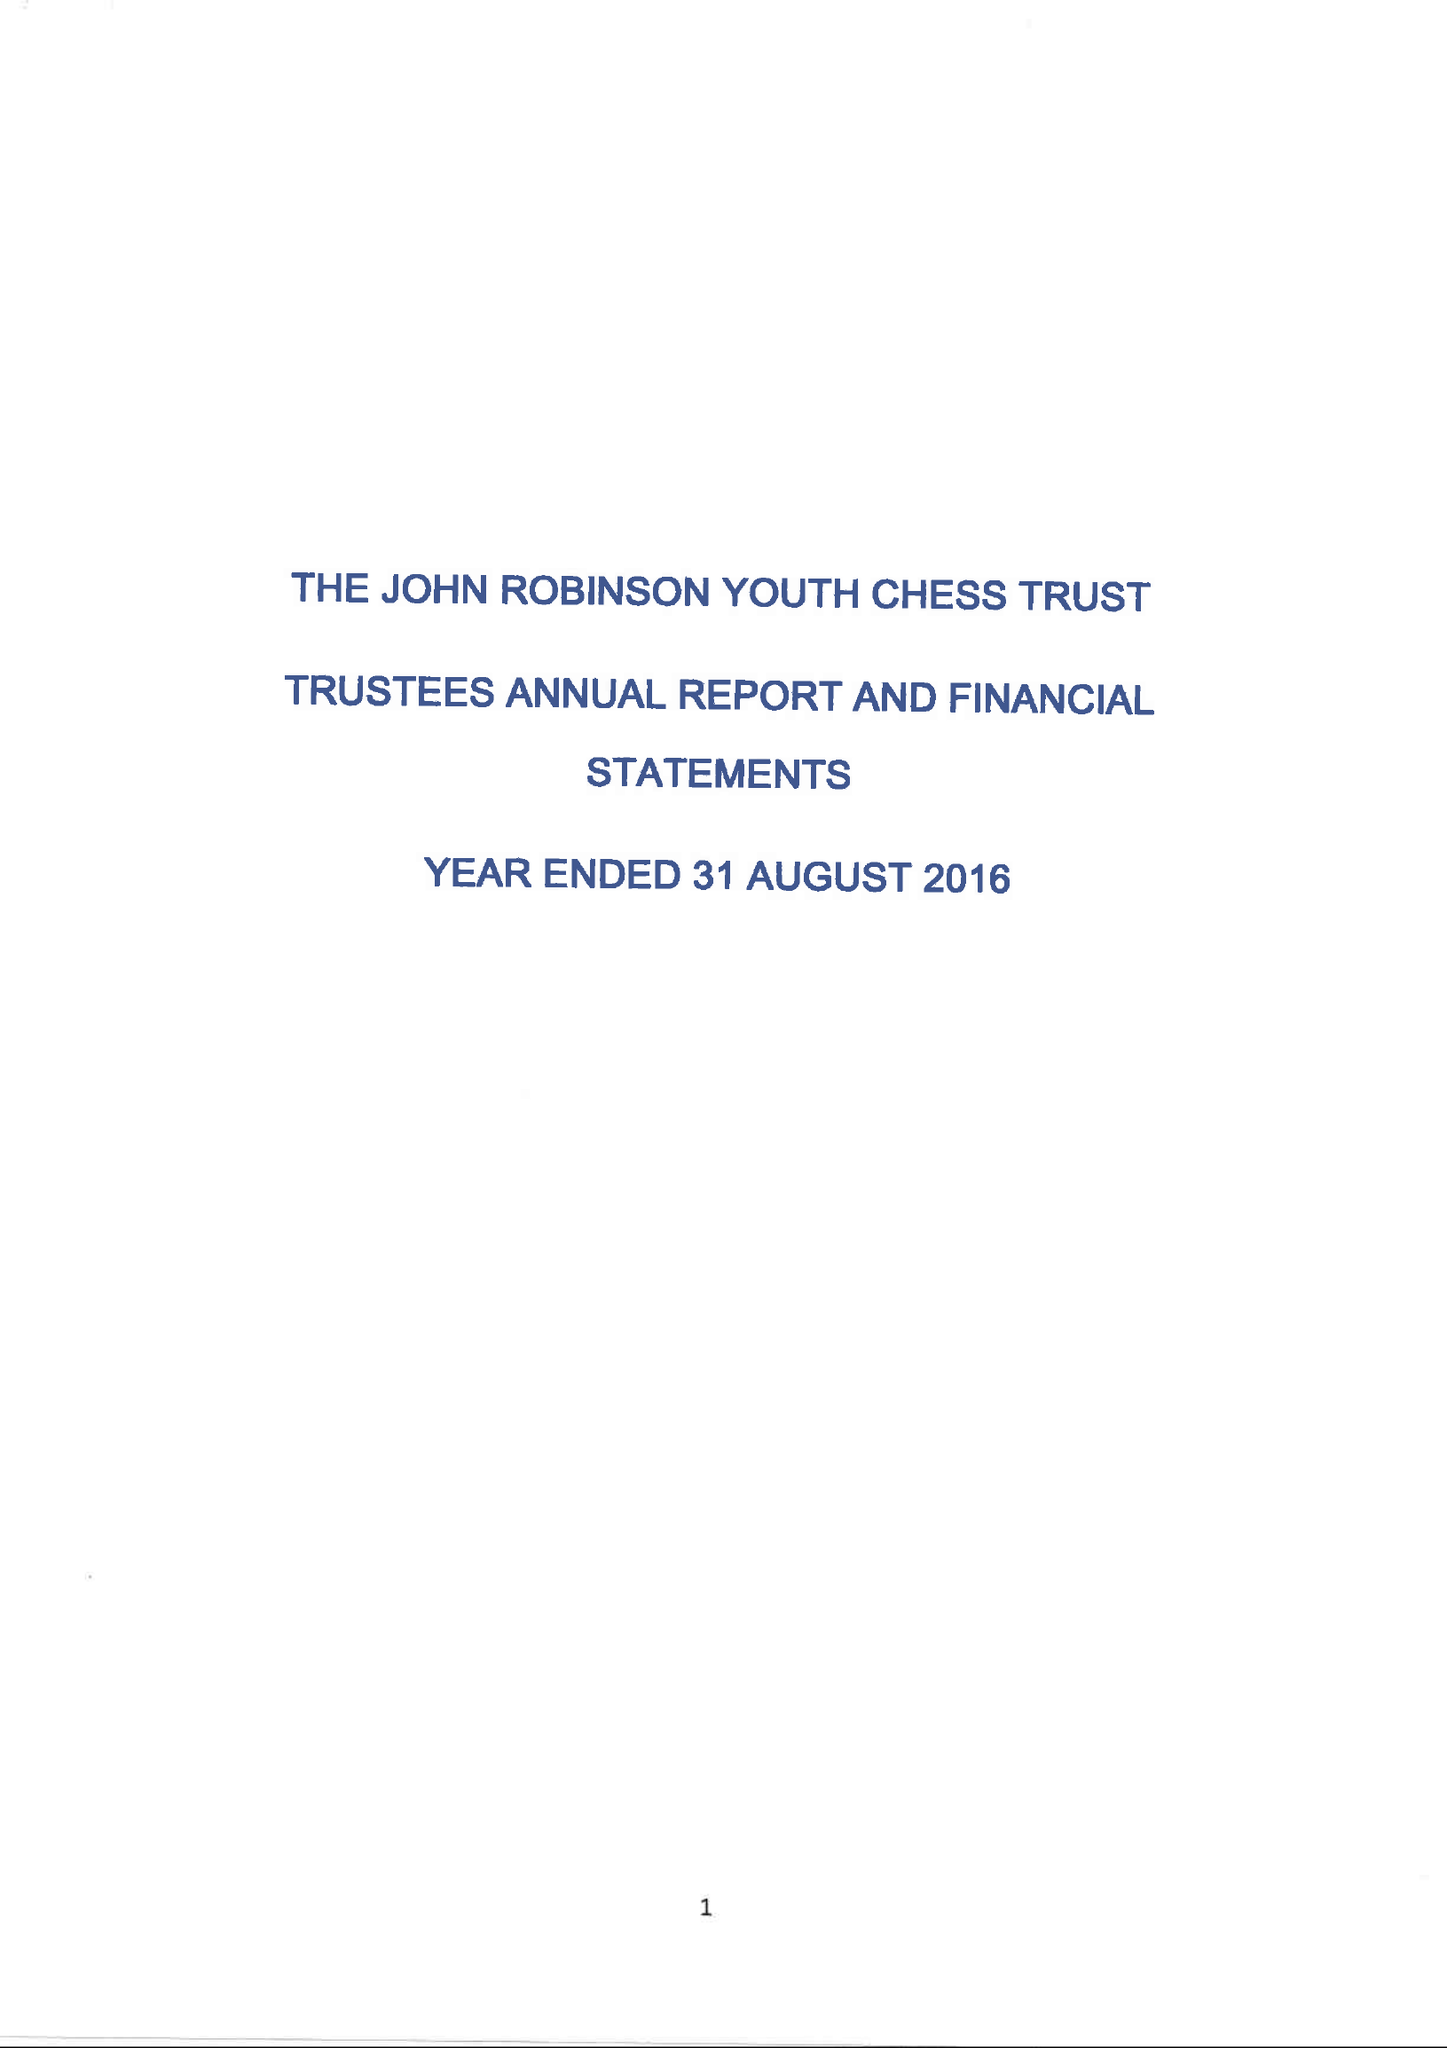What is the value for the address__street_line?
Answer the question using a single word or phrase. 6 MAYFIELD 